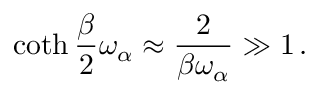Convert formula to latex. <formula><loc_0><loc_0><loc_500><loc_500>\coth { \frac { \beta } { 2 } } \omega _ { \alpha } \approx { \frac { 2 } { \beta \omega _ { \alpha } } } \gg 1 \, .</formula> 